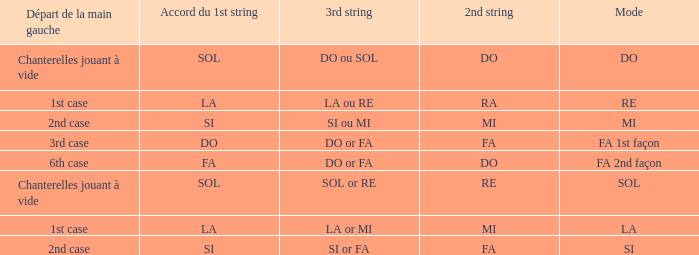What is the mode of the Depart de la main gauche of 1st case and a la or mi 3rd string? LA. 